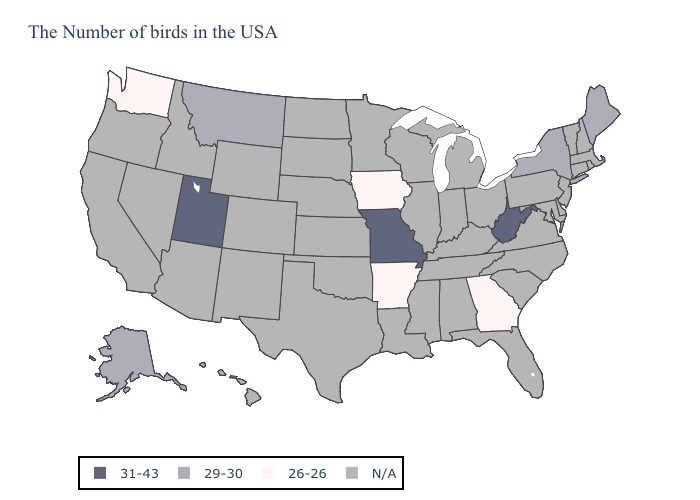Does Washington have the lowest value in the USA?
Keep it brief. Yes. Name the states that have a value in the range 26-26?
Quick response, please. Georgia, Arkansas, Iowa, Washington. Among the states that border Wyoming , which have the highest value?
Give a very brief answer. Utah. Name the states that have a value in the range N/A?
Give a very brief answer. Massachusetts, Rhode Island, New Hampshire, Vermont, Connecticut, New Jersey, Delaware, Maryland, Pennsylvania, Virginia, North Carolina, South Carolina, Ohio, Florida, Michigan, Kentucky, Indiana, Alabama, Tennessee, Wisconsin, Illinois, Mississippi, Louisiana, Minnesota, Kansas, Nebraska, Oklahoma, Texas, South Dakota, North Dakota, Wyoming, Colorado, New Mexico, Arizona, Idaho, Nevada, California, Oregon, Hawaii. What is the value of Indiana?
Be succinct. N/A. What is the value of North Dakota?
Answer briefly. N/A. Name the states that have a value in the range 26-26?
Write a very short answer. Georgia, Arkansas, Iowa, Washington. How many symbols are there in the legend?
Write a very short answer. 4. Is the legend a continuous bar?
Give a very brief answer. No. Does Utah have the highest value in the USA?
Quick response, please. Yes. Which states have the lowest value in the USA?
Quick response, please. Georgia, Arkansas, Iowa, Washington. Name the states that have a value in the range 31-43?
Quick response, please. West Virginia, Missouri, Utah. Does the first symbol in the legend represent the smallest category?
Short answer required. No. 